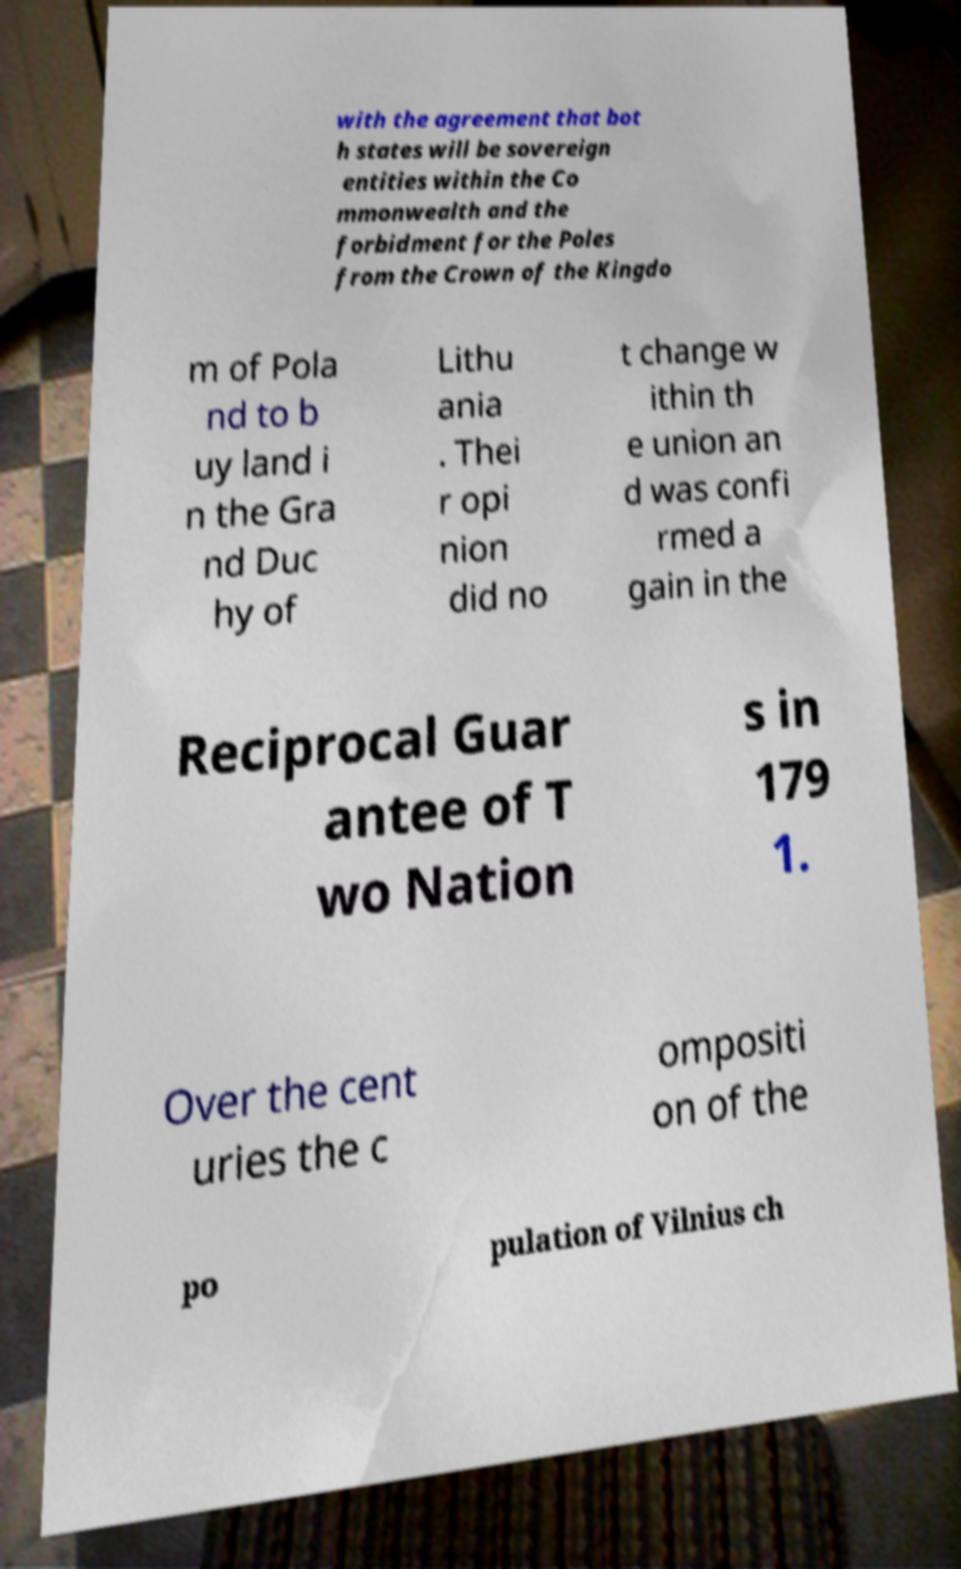There's text embedded in this image that I need extracted. Can you transcribe it verbatim? with the agreement that bot h states will be sovereign entities within the Co mmonwealth and the forbidment for the Poles from the Crown of the Kingdo m of Pola nd to b uy land i n the Gra nd Duc hy of Lithu ania . Thei r opi nion did no t change w ithin th e union an d was confi rmed a gain in the Reciprocal Guar antee of T wo Nation s in 179 1. Over the cent uries the c ompositi on of the po pulation of Vilnius ch 